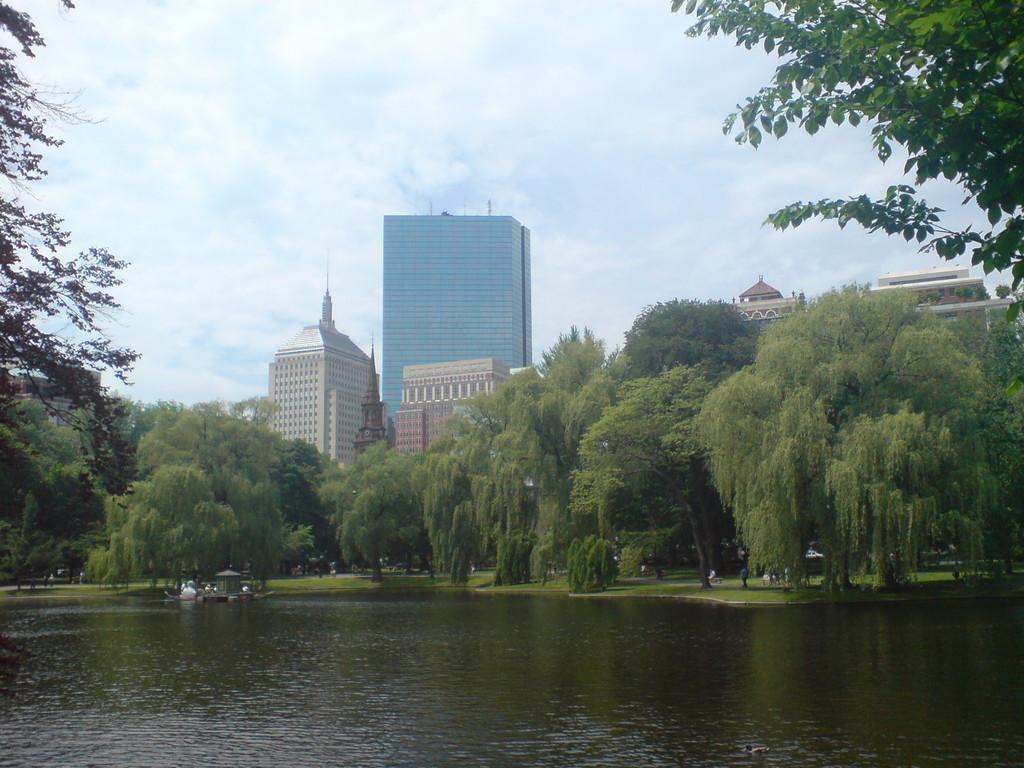What type of natural environment is visible in the image? There are trees around the water in the image. What type of structures can be seen in the background of the image? There are buildings visible in the background of the image. What is visible at the top of the image? The sky is visible at the top of the image. What can be observed in the sky? Clouds are present in the sky. What is the temper of the daughter in the image? There is no daughter present in the image. What type of power is being generated by the trees in the image? The trees in the image are not generating any power; they are simply part of the natural environment. 